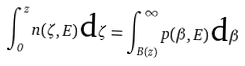Convert formula to latex. <formula><loc_0><loc_0><loc_500><loc_500>\int _ { 0 } ^ { z } n ( \zeta , E ) \, \text {d} \zeta = \int _ { B ( z ) } ^ { \infty } p ( \beta , E ) \, \text {d} \beta</formula> 